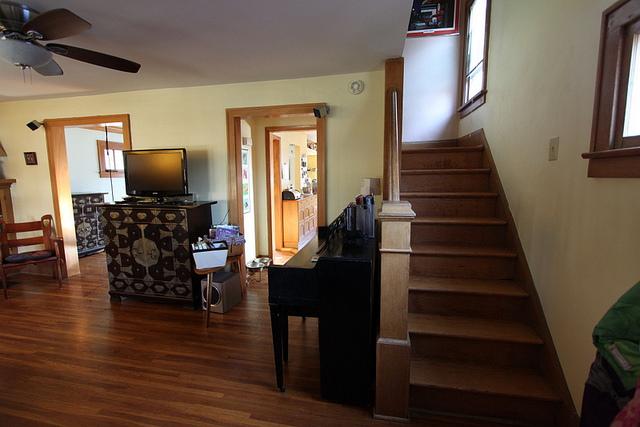What is on the floor?
Short answer required. Wood. What is the type of the flooring this house has?
Keep it brief. Wood. Where might there be a sofa?
Keep it brief. In living room. Is the fan on?
Short answer required. No. What is placed on top of the black table?
Write a very short answer. Tv. Is there a ceiling fan in the room?
Concise answer only. Yes. Does this room look clean?
Write a very short answer. Yes. 